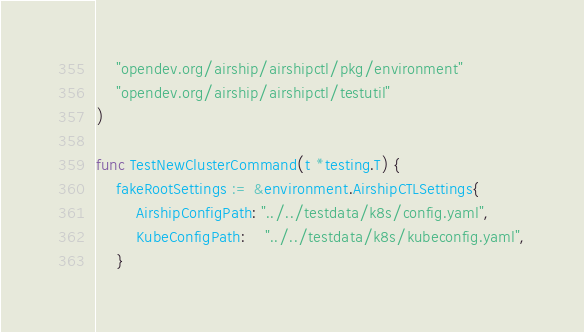<code> <loc_0><loc_0><loc_500><loc_500><_Go_>	"opendev.org/airship/airshipctl/pkg/environment"
	"opendev.org/airship/airshipctl/testutil"
)

func TestNewClusterCommand(t *testing.T) {
	fakeRootSettings := &environment.AirshipCTLSettings{
		AirshipConfigPath: "../../testdata/k8s/config.yaml",
		KubeConfigPath:    "../../testdata/k8s/kubeconfig.yaml",
	}</code> 